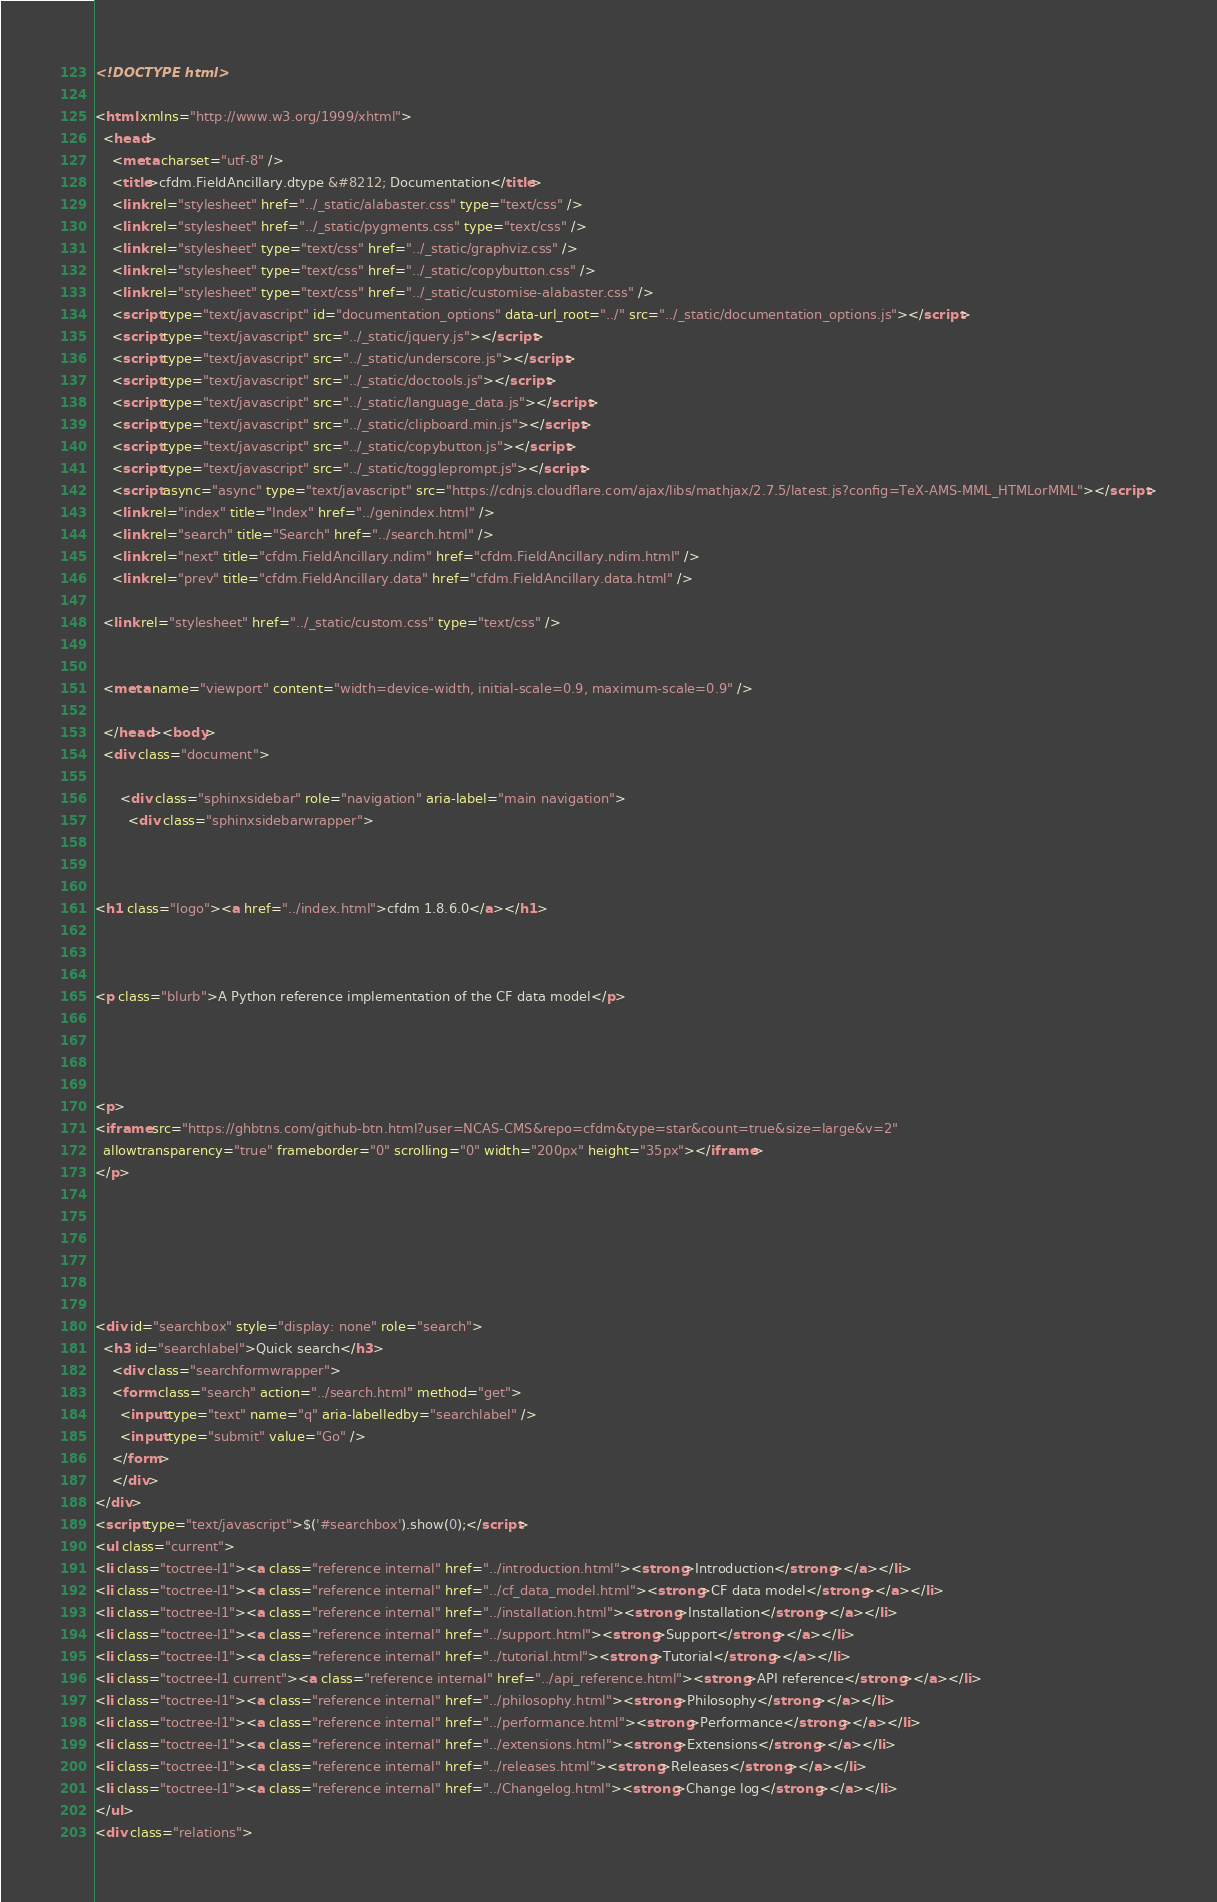<code> <loc_0><loc_0><loc_500><loc_500><_HTML_>
<!DOCTYPE html>

<html xmlns="http://www.w3.org/1999/xhtml">
  <head>
    <meta charset="utf-8" />
    <title>cfdm.FieldAncillary.dtype &#8212; Documentation</title>
    <link rel="stylesheet" href="../_static/alabaster.css" type="text/css" />
    <link rel="stylesheet" href="../_static/pygments.css" type="text/css" />
    <link rel="stylesheet" type="text/css" href="../_static/graphviz.css" />
    <link rel="stylesheet" type="text/css" href="../_static/copybutton.css" />
    <link rel="stylesheet" type="text/css" href="../_static/customise-alabaster.css" />
    <script type="text/javascript" id="documentation_options" data-url_root="../" src="../_static/documentation_options.js"></script>
    <script type="text/javascript" src="../_static/jquery.js"></script>
    <script type="text/javascript" src="../_static/underscore.js"></script>
    <script type="text/javascript" src="../_static/doctools.js"></script>
    <script type="text/javascript" src="../_static/language_data.js"></script>
    <script type="text/javascript" src="../_static/clipboard.min.js"></script>
    <script type="text/javascript" src="../_static/copybutton.js"></script>
    <script type="text/javascript" src="../_static/toggleprompt.js"></script>
    <script async="async" type="text/javascript" src="https://cdnjs.cloudflare.com/ajax/libs/mathjax/2.7.5/latest.js?config=TeX-AMS-MML_HTMLorMML"></script>
    <link rel="index" title="Index" href="../genindex.html" />
    <link rel="search" title="Search" href="../search.html" />
    <link rel="next" title="cfdm.FieldAncillary.ndim" href="cfdm.FieldAncillary.ndim.html" />
    <link rel="prev" title="cfdm.FieldAncillary.data" href="cfdm.FieldAncillary.data.html" />
   
  <link rel="stylesheet" href="../_static/custom.css" type="text/css" />
  
  
  <meta name="viewport" content="width=device-width, initial-scale=0.9, maximum-scale=0.9" />

  </head><body>
  <div class="document">
    
      <div class="sphinxsidebar" role="navigation" aria-label="main navigation">
        <div class="sphinxsidebarwrapper">



<h1 class="logo"><a href="../index.html">cfdm 1.8.6.0</a></h1>



<p class="blurb">A Python reference implementation of the CF data model</p>




<p>
<iframe src="https://ghbtns.com/github-btn.html?user=NCAS-CMS&repo=cfdm&type=star&count=true&size=large&v=2"
  allowtransparency="true" frameborder="0" scrolling="0" width="200px" height="35px"></iframe>
</p>






<div id="searchbox" style="display: none" role="search">
  <h3 id="searchlabel">Quick search</h3>
    <div class="searchformwrapper">
    <form class="search" action="../search.html" method="get">
      <input type="text" name="q" aria-labelledby="searchlabel" />
      <input type="submit" value="Go" />
    </form>
    </div>
</div>
<script type="text/javascript">$('#searchbox').show(0);</script>
<ul class="current">
<li class="toctree-l1"><a class="reference internal" href="../introduction.html"><strong>Introduction</strong></a></li>
<li class="toctree-l1"><a class="reference internal" href="../cf_data_model.html"><strong>CF data model</strong></a></li>
<li class="toctree-l1"><a class="reference internal" href="../installation.html"><strong>Installation</strong></a></li>
<li class="toctree-l1"><a class="reference internal" href="../support.html"><strong>Support</strong></a></li>
<li class="toctree-l1"><a class="reference internal" href="../tutorial.html"><strong>Tutorial</strong></a></li>
<li class="toctree-l1 current"><a class="reference internal" href="../api_reference.html"><strong>API reference</strong></a></li>
<li class="toctree-l1"><a class="reference internal" href="../philosophy.html"><strong>Philosophy</strong></a></li>
<li class="toctree-l1"><a class="reference internal" href="../performance.html"><strong>Performance</strong></a></li>
<li class="toctree-l1"><a class="reference internal" href="../extensions.html"><strong>Extensions</strong></a></li>
<li class="toctree-l1"><a class="reference internal" href="../releases.html"><strong>Releases</strong></a></li>
<li class="toctree-l1"><a class="reference internal" href="../Changelog.html"><strong>Change log</strong></a></li>
</ul>
<div class="relations"></code> 